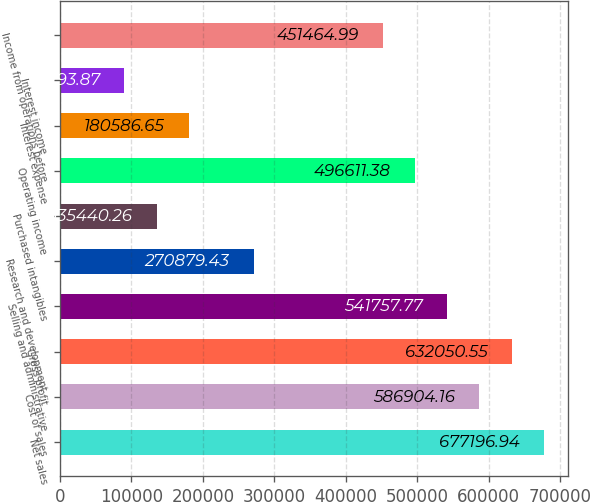Convert chart. <chart><loc_0><loc_0><loc_500><loc_500><bar_chart><fcel>Net sales<fcel>Cost of sales<fcel>Gross profit<fcel>Selling and administrative<fcel>Research and development<fcel>Purchased intangibles<fcel>Operating income<fcel>Interest expense<fcel>Interest income<fcel>Income from operations before<nl><fcel>677197<fcel>586904<fcel>632051<fcel>541758<fcel>270879<fcel>135440<fcel>496611<fcel>180587<fcel>90293.9<fcel>451465<nl></chart> 